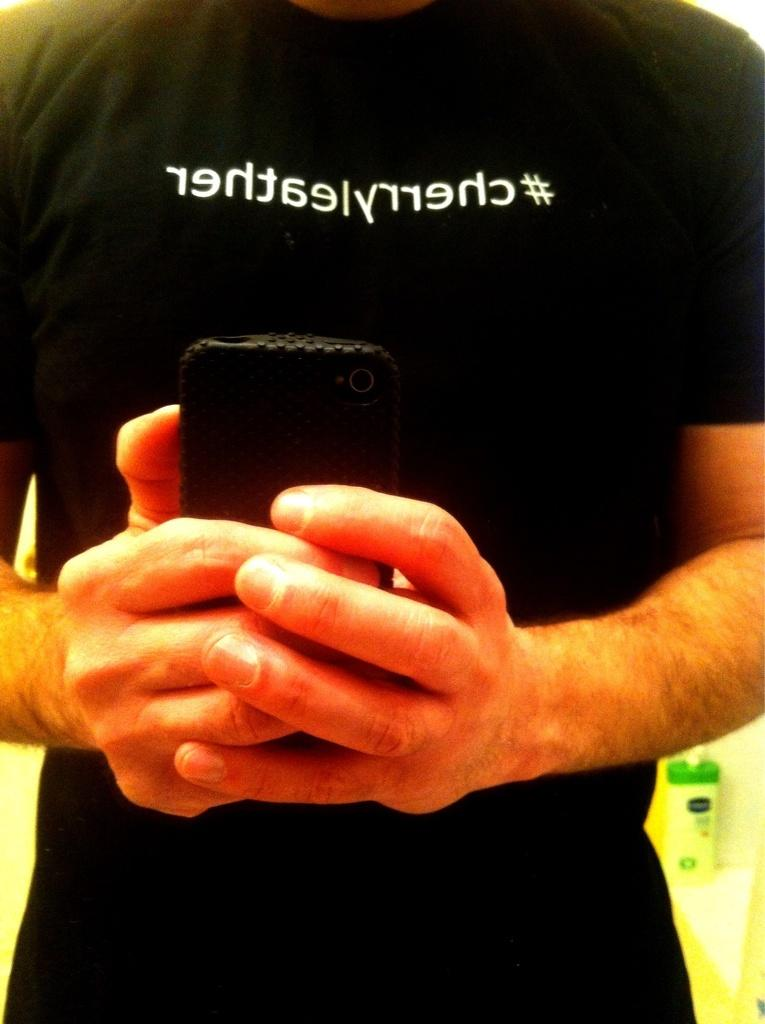What is the main subject of the image? A: There is a person in the image. What is the person wearing? The person is wearing a black t-shirt. What is the person holding in the image? The person is holding a mobile with his hands. What can be seen on the black t-shirt? There is something written on the black t-shirt. What else is visible in the image? There is a bottle visible in the image. What type of goat can be seen singing a song in the image? There is no goat or singing in the image; it features a person holding a mobile and wearing a black t-shirt with writing on it. 